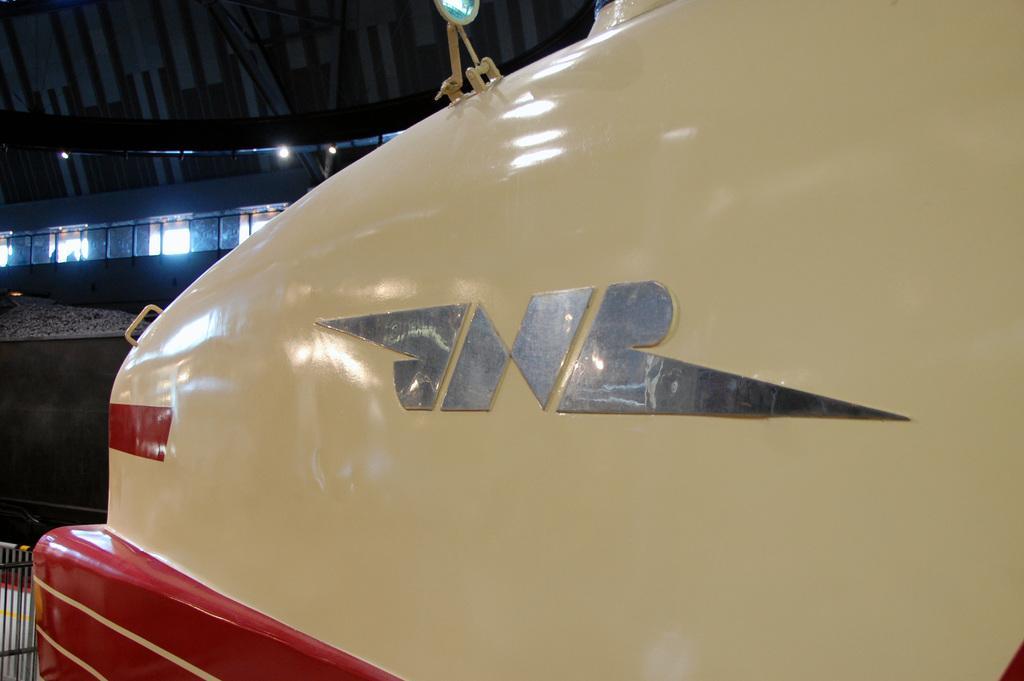How would you summarize this image in a sentence or two? In this image, we can see a vehicle. 